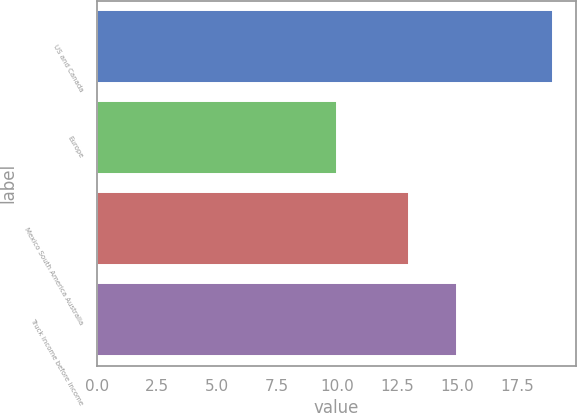Convert chart. <chart><loc_0><loc_0><loc_500><loc_500><bar_chart><fcel>US and Canada<fcel>Europe<fcel>Mexico South America Australia<fcel>Truck income before income<nl><fcel>19<fcel>10<fcel>13<fcel>15<nl></chart> 